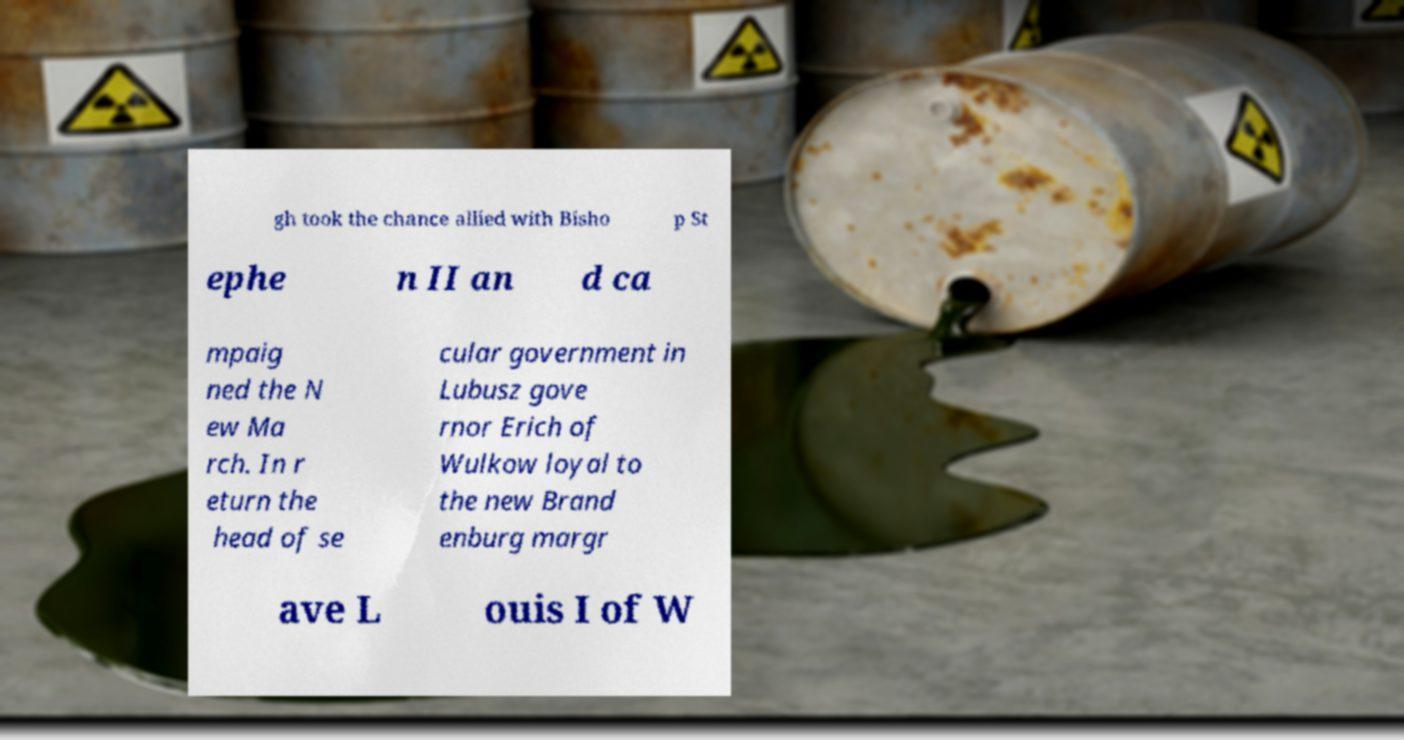Could you assist in decoding the text presented in this image and type it out clearly? gh took the chance allied with Bisho p St ephe n II an d ca mpaig ned the N ew Ma rch. In r eturn the head of se cular government in Lubusz gove rnor Erich of Wulkow loyal to the new Brand enburg margr ave L ouis I of W 